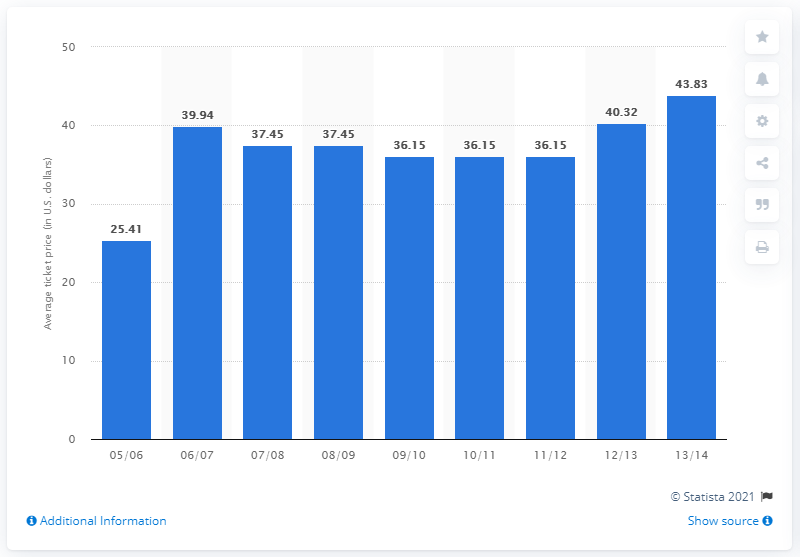Mention a couple of crucial points in this snapshot. The average ticket price for a Coyotes game in the 2005/2006 season was 25.41. 